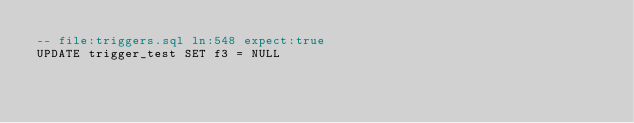Convert code to text. <code><loc_0><loc_0><loc_500><loc_500><_SQL_>-- file:triggers.sql ln:548 expect:true
UPDATE trigger_test SET f3 = NULL
</code> 